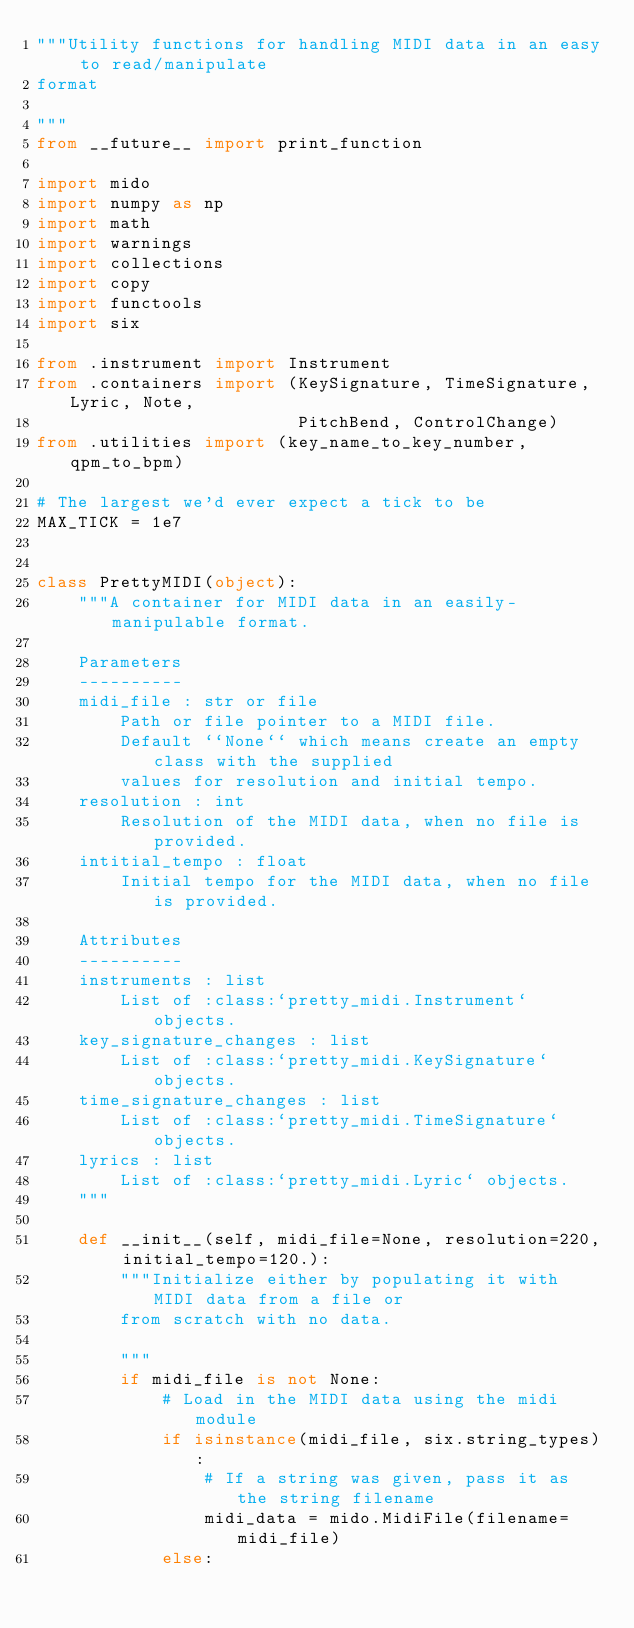Convert code to text. <code><loc_0><loc_0><loc_500><loc_500><_Python_>"""Utility functions for handling MIDI data in an easy to read/manipulate
format

"""
from __future__ import print_function

import mido
import numpy as np
import math
import warnings
import collections
import copy
import functools
import six

from .instrument import Instrument
from .containers import (KeySignature, TimeSignature, Lyric, Note,
                         PitchBend, ControlChange)
from .utilities import (key_name_to_key_number, qpm_to_bpm)

# The largest we'd ever expect a tick to be
MAX_TICK = 1e7


class PrettyMIDI(object):
    """A container for MIDI data in an easily-manipulable format.

    Parameters
    ----------
    midi_file : str or file
        Path or file pointer to a MIDI file.
        Default ``None`` which means create an empty class with the supplied
        values for resolution and initial tempo.
    resolution : int
        Resolution of the MIDI data, when no file is provided.
    intitial_tempo : float
        Initial tempo for the MIDI data, when no file is provided.

    Attributes
    ----------
    instruments : list
        List of :class:`pretty_midi.Instrument` objects.
    key_signature_changes : list
        List of :class:`pretty_midi.KeySignature` objects.
    time_signature_changes : list
        List of :class:`pretty_midi.TimeSignature` objects.
    lyrics : list
        List of :class:`pretty_midi.Lyric` objects.
    """

    def __init__(self, midi_file=None, resolution=220, initial_tempo=120.):
        """Initialize either by populating it with MIDI data from a file or
        from scratch with no data.

        """
        if midi_file is not None:
            # Load in the MIDI data using the midi module
            if isinstance(midi_file, six.string_types):
                # If a string was given, pass it as the string filename
                midi_data = mido.MidiFile(filename=midi_file)
            else:</code> 